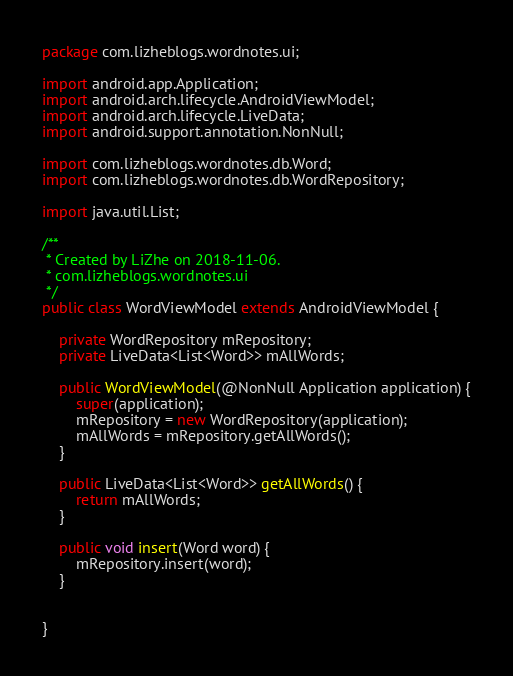<code> <loc_0><loc_0><loc_500><loc_500><_Java_>package com.lizheblogs.wordnotes.ui;

import android.app.Application;
import android.arch.lifecycle.AndroidViewModel;
import android.arch.lifecycle.LiveData;
import android.support.annotation.NonNull;

import com.lizheblogs.wordnotes.db.Word;
import com.lizheblogs.wordnotes.db.WordRepository;

import java.util.List;

/**
 * Created by LiZhe on 2018-11-06.
 * com.lizheblogs.wordnotes.ui
 */
public class WordViewModel extends AndroidViewModel {

    private WordRepository mRepository;
    private LiveData<List<Word>> mAllWords;

    public WordViewModel(@NonNull Application application) {
        super(application);
        mRepository = new WordRepository(application);
        mAllWords = mRepository.getAllWords();
    }

    public LiveData<List<Word>> getAllWords() {
        return mAllWords;
    }

    public void insert(Word word) {
        mRepository.insert(word);
    }


}
</code> 